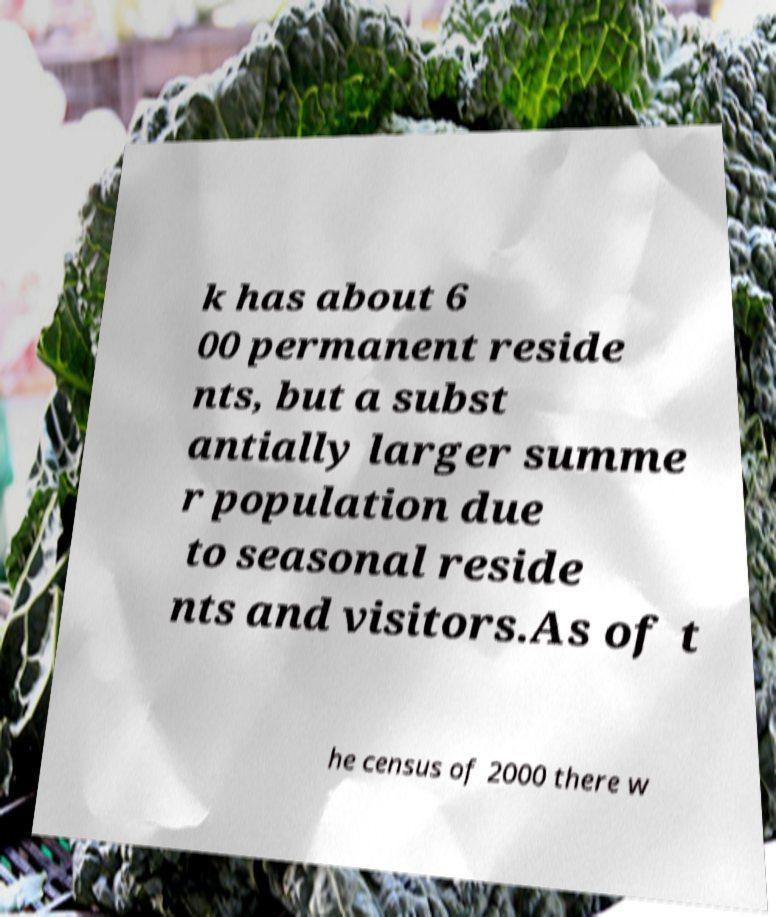Could you extract and type out the text from this image? k has about 6 00 permanent reside nts, but a subst antially larger summe r population due to seasonal reside nts and visitors.As of t he census of 2000 there w 